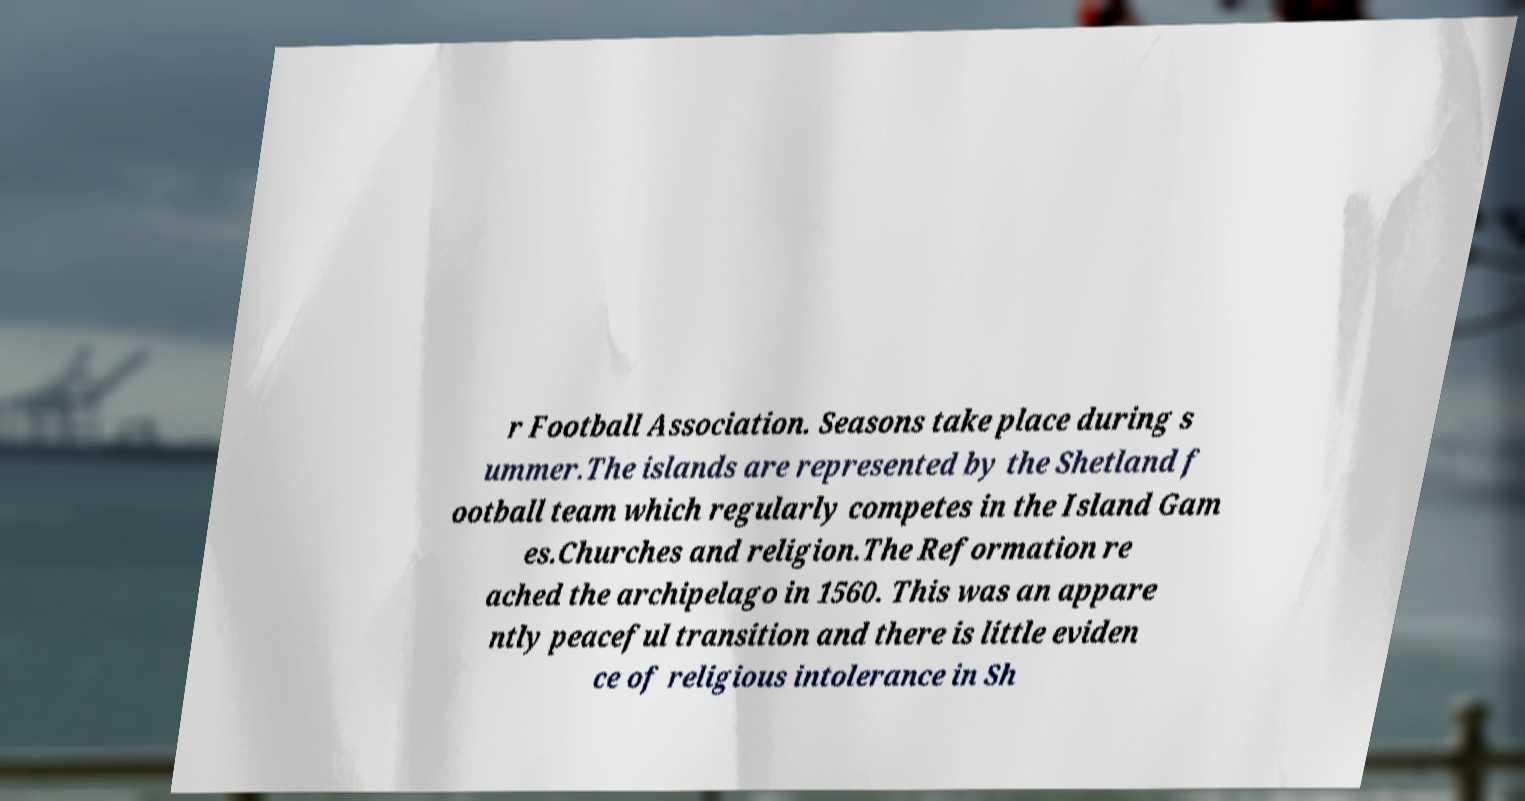For documentation purposes, I need the text within this image transcribed. Could you provide that? r Football Association. Seasons take place during s ummer.The islands are represented by the Shetland f ootball team which regularly competes in the Island Gam es.Churches and religion.The Reformation re ached the archipelago in 1560. This was an appare ntly peaceful transition and there is little eviden ce of religious intolerance in Sh 